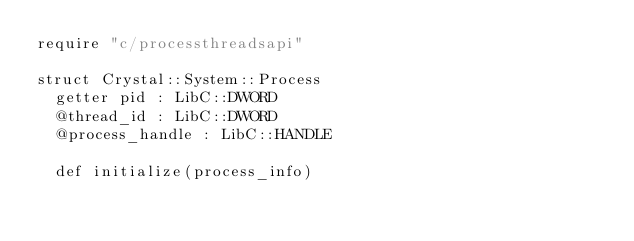Convert code to text. <code><loc_0><loc_0><loc_500><loc_500><_Crystal_>require "c/processthreadsapi"

struct Crystal::System::Process
  getter pid : LibC::DWORD
  @thread_id : LibC::DWORD
  @process_handle : LibC::HANDLE

  def initialize(process_info)</code> 